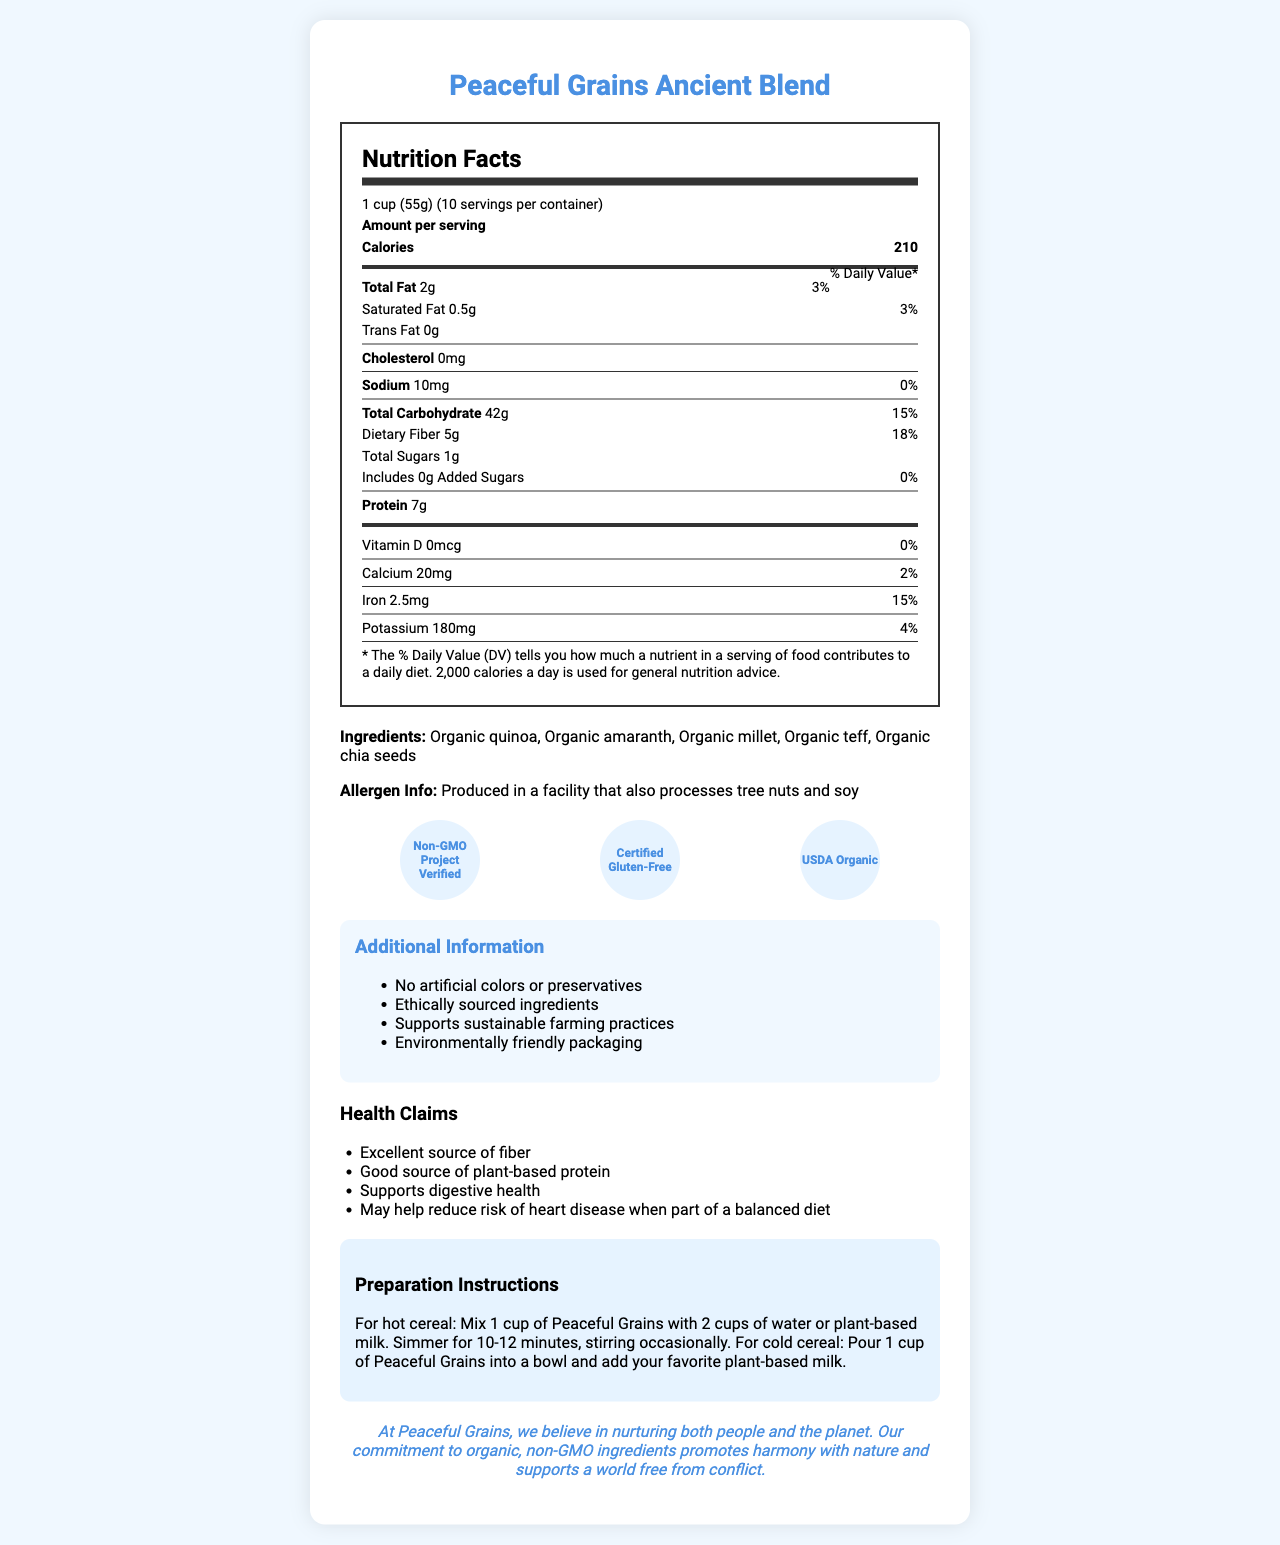what is the serving size? The serving size is stated at the very beginning of the Nutrition Facts section as "1 cup (55g)".
Answer: 1 cup (55g) how many servings are there per container? The document mentions "10 servings per container" right after the serving size information.
Answer: 10 how many total calories are in one serving? Right after the serving size, it specifies that each serving contains 210 calories.
Answer: 210 what allergen information is provided? The allergen information is clearly stated in the "Ingredients" section.
Answer: Produced in a facility that also processes tree nuts and soy which certifications does this product have? The certifications are listed under the "certifications" section in the document.
Answer: Non-GMO Project Verified, Certified Gluten-Free, USDA Organic what is the amount of dietary fiber per serving? The dietary fiber amount is listed as 5g under the "total carbohydrate" section of the nutrition facts.
Answer: 5g What is the percentage of daily value for iron in one serving? The daily value percentage for iron is shown as 15% in the nutrition facts section, under the "Iron" heading.
Answer: 15% where should the cereal be prepared for hot consumption, and for how long? The preparation instructions provide these steps for preparing hot cereal.
Answer: Mix 1 cup of Peaceful Grains with 2 cups of water or plant-based milk. Simmer for 10-12 minutes, stirring occasionally. when can this cereal support heart health? A. When consumed weekly B. When part of a balanced diet C. As a meal replacement The health claims section mentions that it "May help reduce risk of heart disease when part of a balanced diet."
Answer: B how many grams of total fat are in one serving? A. 1g B. 2g C. 5g D. 7g The total fat content per serving is listed as 2g in the nutrition facts section.
Answer: B is this product gluten-free? The product is certified as gluten-free, as indicated under the certifications section.
Answer: Yes summarize the main idea of the document. The document details the product name, nutritional information, ingredients, allergen info, certifications, additional information about ethical sourcing and sustainability, health claims, preparation instructions, and the company's mission.
Answer: Peaceful Grains Ancient Blend is a non-GMO, gluten-free breakfast cereal made from organic ancient grains. It is high in fiber, plant-based protein and supports heart and digestive health. The product is sustainably sourced and packaged. how long does it take to simmer the cereal for hot consumption? Although the preparation instructions mention simmering, the specific duration is not provided in the instructions that can be seen in the document.
Answer: Cannot be determined how many mg of calcium does one serving provide? The calcium content is specified as 20mg per serving under the nutrition facts section.
Answer: 20mg what type of grains does this cereal contain? The ingredients list specifies these types of grains.
Answer: Organic quinoa, organic amaranth, organic millet, organic teff, organic chia seeds what organization verifies that the product is non-GMO? A. USDA B. Non-GMO Project C. Gluten-Free Certification Organization D. FDA The document states that the product is "Non-GMO Project Verified".
Answer: B how many total sugars does one serving contain? The total sugars per serving are listed as 1g in the nutrition facts section.
Answer: 1g 